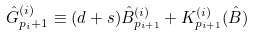Convert formula to latex. <formula><loc_0><loc_0><loc_500><loc_500>{ \hat { G } } ^ { ( i ) } _ { p _ { i } + 1 } \equiv ( d + s ) { \hat { B } } ^ { ( i ) } _ { p _ { i + 1 } } + { K } ^ { ( i ) } _ { p _ { i + 1 } } ( \hat { B } )</formula> 